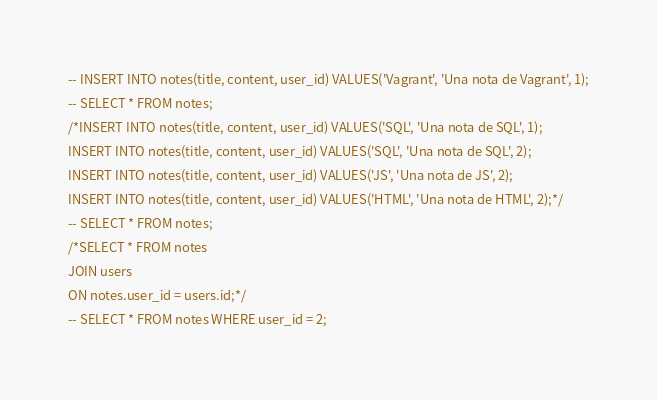Convert code to text. <code><loc_0><loc_0><loc_500><loc_500><_SQL_>-- INSERT INTO notes(title, content, user_id) VALUES('Vagrant', 'Una nota de Vagrant', 1);
-- SELECT * FROM notes;
/*INSERT INTO notes(title, content, user_id) VALUES('SQL', 'Una nota de SQL', 1);
INSERT INTO notes(title, content, user_id) VALUES('SQL', 'Una nota de SQL', 2);
INSERT INTO notes(title, content, user_id) VALUES('JS', 'Una nota de JS', 2);
INSERT INTO notes(title, content, user_id) VALUES('HTML', 'Una nota de HTML', 2);*/
-- SELECT * FROM notes;
/*SELECT * FROM notes
JOIN users
ON notes.user_id = users.id;*/
-- SELECT * FROM notes WHERE user_id = 2;</code> 